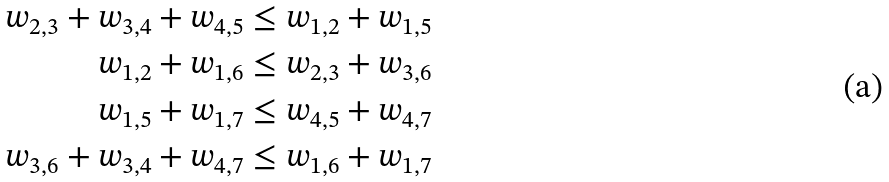Convert formula to latex. <formula><loc_0><loc_0><loc_500><loc_500>w _ { 2 , 3 } + w _ { 3 , 4 } + w _ { 4 , 5 } & \leq w _ { 1 , 2 } + w _ { 1 , 5 } \\ w _ { 1 , 2 } + w _ { 1 , 6 } & \leq w _ { 2 , 3 } + w _ { 3 , 6 } \\ w _ { 1 , 5 } + w _ { 1 , 7 } & \leq w _ { 4 , 5 } + w _ { 4 , 7 } \\ w _ { 3 , 6 } + w _ { 3 , 4 } + w _ { 4 , 7 } & \leq w _ { 1 , 6 } + w _ { 1 , 7 } \\</formula> 